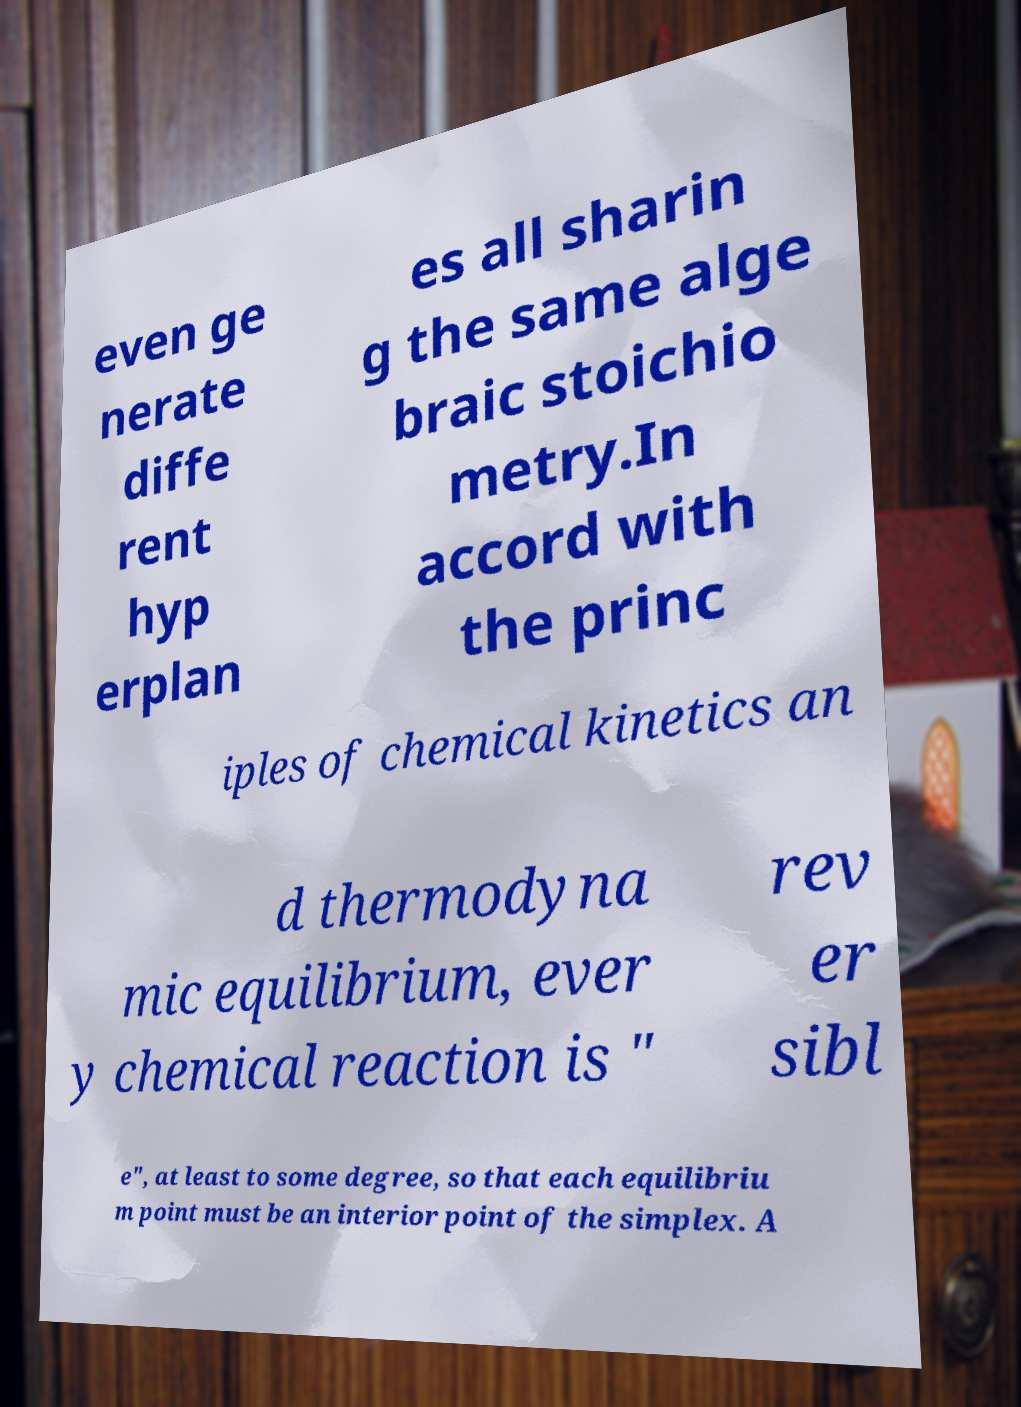What messages or text are displayed in this image? I need them in a readable, typed format. even ge nerate diffe rent hyp erplan es all sharin g the same alge braic stoichio metry.In accord with the princ iples of chemical kinetics an d thermodyna mic equilibrium, ever y chemical reaction is " rev er sibl e", at least to some degree, so that each equilibriu m point must be an interior point of the simplex. A 